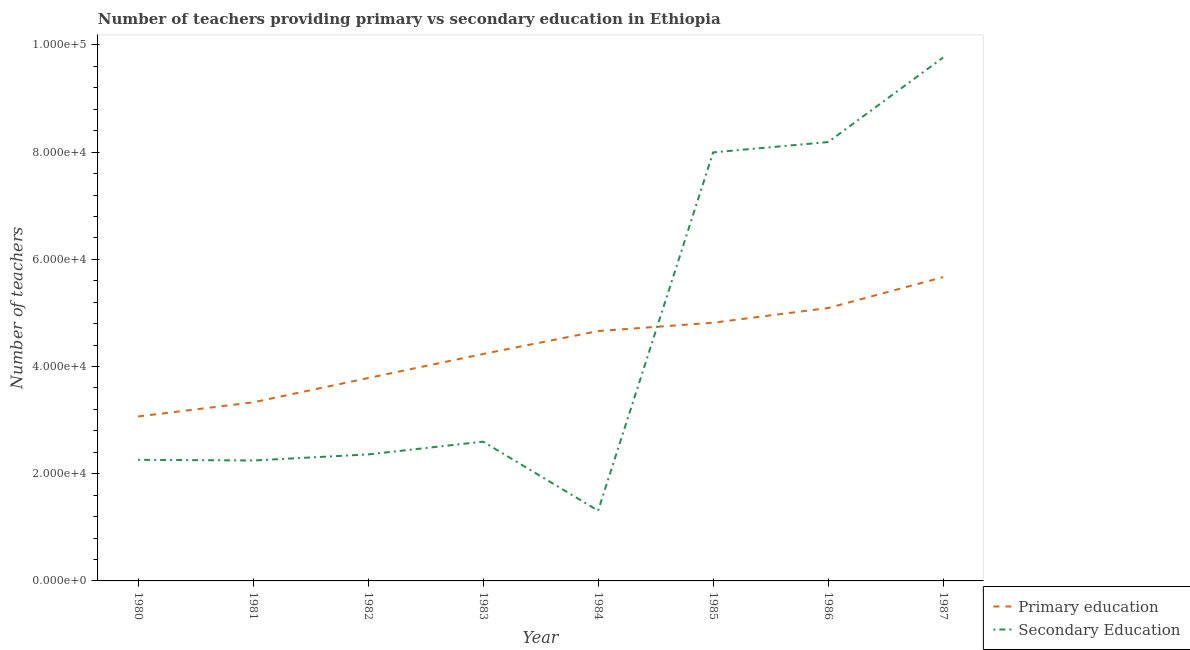How many different coloured lines are there?
Make the answer very short. 2. Is the number of lines equal to the number of legend labels?
Give a very brief answer. Yes. What is the number of primary teachers in 1980?
Ensure brevity in your answer.  3.07e+04. Across all years, what is the maximum number of secondary teachers?
Give a very brief answer. 9.77e+04. Across all years, what is the minimum number of primary teachers?
Make the answer very short. 3.07e+04. What is the total number of secondary teachers in the graph?
Offer a terse response. 3.67e+05. What is the difference between the number of secondary teachers in 1980 and that in 1982?
Ensure brevity in your answer.  -1005. What is the difference between the number of primary teachers in 1987 and the number of secondary teachers in 1984?
Provide a short and direct response. 4.36e+04. What is the average number of secondary teachers per year?
Provide a succinct answer. 4.59e+04. In the year 1982, what is the difference between the number of secondary teachers and number of primary teachers?
Your answer should be compact. -1.42e+04. In how many years, is the number of primary teachers greater than 88000?
Offer a terse response. 0. What is the ratio of the number of primary teachers in 1984 to that in 1987?
Give a very brief answer. 0.82. What is the difference between the highest and the second highest number of primary teachers?
Make the answer very short. 5762. What is the difference between the highest and the lowest number of secondary teachers?
Your answer should be very brief. 8.46e+04. Is the number of primary teachers strictly less than the number of secondary teachers over the years?
Your answer should be compact. No. How many legend labels are there?
Ensure brevity in your answer.  2. How are the legend labels stacked?
Make the answer very short. Vertical. What is the title of the graph?
Provide a succinct answer. Number of teachers providing primary vs secondary education in Ethiopia. What is the label or title of the Y-axis?
Offer a terse response. Number of teachers. What is the Number of teachers of Primary education in 1980?
Make the answer very short. 3.07e+04. What is the Number of teachers in Secondary Education in 1980?
Keep it short and to the point. 2.26e+04. What is the Number of teachers in Primary education in 1981?
Your response must be concise. 3.33e+04. What is the Number of teachers of Secondary Education in 1981?
Keep it short and to the point. 2.25e+04. What is the Number of teachers of Primary education in 1982?
Your answer should be very brief. 3.79e+04. What is the Number of teachers in Secondary Education in 1982?
Your answer should be very brief. 2.36e+04. What is the Number of teachers of Primary education in 1983?
Your answer should be compact. 4.23e+04. What is the Number of teachers in Secondary Education in 1983?
Your answer should be very brief. 2.60e+04. What is the Number of teachers of Primary education in 1984?
Keep it short and to the point. 4.66e+04. What is the Number of teachers of Secondary Education in 1984?
Provide a short and direct response. 1.31e+04. What is the Number of teachers in Primary education in 1985?
Ensure brevity in your answer.  4.82e+04. What is the Number of teachers of Secondary Education in 1985?
Make the answer very short. 8.00e+04. What is the Number of teachers in Primary education in 1986?
Give a very brief answer. 5.09e+04. What is the Number of teachers of Secondary Education in 1986?
Your answer should be very brief. 8.19e+04. What is the Number of teachers in Primary education in 1987?
Offer a very short reply. 5.67e+04. What is the Number of teachers in Secondary Education in 1987?
Give a very brief answer. 9.77e+04. Across all years, what is the maximum Number of teachers in Primary education?
Provide a succinct answer. 5.67e+04. Across all years, what is the maximum Number of teachers of Secondary Education?
Offer a very short reply. 9.77e+04. Across all years, what is the minimum Number of teachers of Primary education?
Your answer should be compact. 3.07e+04. Across all years, what is the minimum Number of teachers in Secondary Education?
Your answer should be compact. 1.31e+04. What is the total Number of teachers in Primary education in the graph?
Make the answer very short. 3.47e+05. What is the total Number of teachers in Secondary Education in the graph?
Make the answer very short. 3.67e+05. What is the difference between the Number of teachers of Primary education in 1980 and that in 1981?
Your answer should be very brief. -2635. What is the difference between the Number of teachers of Secondary Education in 1980 and that in 1981?
Provide a succinct answer. 130. What is the difference between the Number of teachers of Primary education in 1980 and that in 1982?
Make the answer very short. -7167. What is the difference between the Number of teachers of Secondary Education in 1980 and that in 1982?
Provide a short and direct response. -1005. What is the difference between the Number of teachers in Primary education in 1980 and that in 1983?
Offer a very short reply. -1.17e+04. What is the difference between the Number of teachers in Secondary Education in 1980 and that in 1983?
Provide a short and direct response. -3384. What is the difference between the Number of teachers in Primary education in 1980 and that in 1984?
Provide a succinct answer. -1.59e+04. What is the difference between the Number of teachers in Secondary Education in 1980 and that in 1984?
Your response must be concise. 9491. What is the difference between the Number of teachers of Primary education in 1980 and that in 1985?
Make the answer very short. -1.75e+04. What is the difference between the Number of teachers of Secondary Education in 1980 and that in 1985?
Provide a succinct answer. -5.74e+04. What is the difference between the Number of teachers in Primary education in 1980 and that in 1986?
Provide a short and direct response. -2.02e+04. What is the difference between the Number of teachers in Secondary Education in 1980 and that in 1986?
Your answer should be compact. -5.93e+04. What is the difference between the Number of teachers in Primary education in 1980 and that in 1987?
Your response must be concise. -2.60e+04. What is the difference between the Number of teachers in Secondary Education in 1980 and that in 1987?
Provide a short and direct response. -7.51e+04. What is the difference between the Number of teachers of Primary education in 1981 and that in 1982?
Provide a succinct answer. -4532. What is the difference between the Number of teachers of Secondary Education in 1981 and that in 1982?
Ensure brevity in your answer.  -1135. What is the difference between the Number of teachers in Primary education in 1981 and that in 1983?
Provide a short and direct response. -9025. What is the difference between the Number of teachers of Secondary Education in 1981 and that in 1983?
Your answer should be compact. -3514. What is the difference between the Number of teachers of Primary education in 1981 and that in 1984?
Provide a short and direct response. -1.33e+04. What is the difference between the Number of teachers of Secondary Education in 1981 and that in 1984?
Your response must be concise. 9361. What is the difference between the Number of teachers in Primary education in 1981 and that in 1985?
Give a very brief answer. -1.49e+04. What is the difference between the Number of teachers of Secondary Education in 1981 and that in 1985?
Make the answer very short. -5.75e+04. What is the difference between the Number of teachers of Primary education in 1981 and that in 1986?
Offer a terse response. -1.76e+04. What is the difference between the Number of teachers of Secondary Education in 1981 and that in 1986?
Offer a terse response. -5.94e+04. What is the difference between the Number of teachers in Primary education in 1981 and that in 1987?
Ensure brevity in your answer.  -2.34e+04. What is the difference between the Number of teachers in Secondary Education in 1981 and that in 1987?
Your answer should be very brief. -7.52e+04. What is the difference between the Number of teachers in Primary education in 1982 and that in 1983?
Make the answer very short. -4493. What is the difference between the Number of teachers of Secondary Education in 1982 and that in 1983?
Keep it short and to the point. -2379. What is the difference between the Number of teachers in Primary education in 1982 and that in 1984?
Offer a very short reply. -8768. What is the difference between the Number of teachers of Secondary Education in 1982 and that in 1984?
Your answer should be compact. 1.05e+04. What is the difference between the Number of teachers of Primary education in 1982 and that in 1985?
Provide a succinct answer. -1.03e+04. What is the difference between the Number of teachers in Secondary Education in 1982 and that in 1985?
Provide a short and direct response. -5.64e+04. What is the difference between the Number of teachers in Primary education in 1982 and that in 1986?
Offer a very short reply. -1.31e+04. What is the difference between the Number of teachers of Secondary Education in 1982 and that in 1986?
Provide a short and direct response. -5.83e+04. What is the difference between the Number of teachers in Primary education in 1982 and that in 1987?
Ensure brevity in your answer.  -1.88e+04. What is the difference between the Number of teachers of Secondary Education in 1982 and that in 1987?
Give a very brief answer. -7.41e+04. What is the difference between the Number of teachers of Primary education in 1983 and that in 1984?
Your answer should be very brief. -4275. What is the difference between the Number of teachers in Secondary Education in 1983 and that in 1984?
Your response must be concise. 1.29e+04. What is the difference between the Number of teachers in Primary education in 1983 and that in 1985?
Provide a succinct answer. -5831. What is the difference between the Number of teachers in Secondary Education in 1983 and that in 1985?
Your answer should be very brief. -5.40e+04. What is the difference between the Number of teachers in Primary education in 1983 and that in 1986?
Offer a terse response. -8575. What is the difference between the Number of teachers in Secondary Education in 1983 and that in 1986?
Your answer should be compact. -5.59e+04. What is the difference between the Number of teachers in Primary education in 1983 and that in 1987?
Offer a very short reply. -1.43e+04. What is the difference between the Number of teachers of Secondary Education in 1983 and that in 1987?
Offer a terse response. -7.17e+04. What is the difference between the Number of teachers in Primary education in 1984 and that in 1985?
Give a very brief answer. -1556. What is the difference between the Number of teachers of Secondary Education in 1984 and that in 1985?
Your answer should be very brief. -6.69e+04. What is the difference between the Number of teachers of Primary education in 1984 and that in 1986?
Ensure brevity in your answer.  -4300. What is the difference between the Number of teachers in Secondary Education in 1984 and that in 1986?
Make the answer very short. -6.88e+04. What is the difference between the Number of teachers of Primary education in 1984 and that in 1987?
Your answer should be very brief. -1.01e+04. What is the difference between the Number of teachers of Secondary Education in 1984 and that in 1987?
Offer a very short reply. -8.46e+04. What is the difference between the Number of teachers in Primary education in 1985 and that in 1986?
Keep it short and to the point. -2744. What is the difference between the Number of teachers in Secondary Education in 1985 and that in 1986?
Offer a very short reply. -1925. What is the difference between the Number of teachers in Primary education in 1985 and that in 1987?
Keep it short and to the point. -8506. What is the difference between the Number of teachers in Secondary Education in 1985 and that in 1987?
Provide a short and direct response. -1.77e+04. What is the difference between the Number of teachers of Primary education in 1986 and that in 1987?
Offer a very short reply. -5762. What is the difference between the Number of teachers in Secondary Education in 1986 and that in 1987?
Offer a terse response. -1.58e+04. What is the difference between the Number of teachers of Primary education in 1980 and the Number of teachers of Secondary Education in 1981?
Offer a very short reply. 8217. What is the difference between the Number of teachers of Primary education in 1980 and the Number of teachers of Secondary Education in 1982?
Keep it short and to the point. 7082. What is the difference between the Number of teachers of Primary education in 1980 and the Number of teachers of Secondary Education in 1983?
Ensure brevity in your answer.  4703. What is the difference between the Number of teachers in Primary education in 1980 and the Number of teachers in Secondary Education in 1984?
Your answer should be compact. 1.76e+04. What is the difference between the Number of teachers of Primary education in 1980 and the Number of teachers of Secondary Education in 1985?
Offer a terse response. -4.93e+04. What is the difference between the Number of teachers of Primary education in 1980 and the Number of teachers of Secondary Education in 1986?
Offer a very short reply. -5.12e+04. What is the difference between the Number of teachers of Primary education in 1980 and the Number of teachers of Secondary Education in 1987?
Offer a terse response. -6.70e+04. What is the difference between the Number of teachers of Primary education in 1981 and the Number of teachers of Secondary Education in 1982?
Ensure brevity in your answer.  9717. What is the difference between the Number of teachers in Primary education in 1981 and the Number of teachers in Secondary Education in 1983?
Provide a succinct answer. 7338. What is the difference between the Number of teachers in Primary education in 1981 and the Number of teachers in Secondary Education in 1984?
Offer a terse response. 2.02e+04. What is the difference between the Number of teachers in Primary education in 1981 and the Number of teachers in Secondary Education in 1985?
Keep it short and to the point. -4.66e+04. What is the difference between the Number of teachers of Primary education in 1981 and the Number of teachers of Secondary Education in 1986?
Make the answer very short. -4.86e+04. What is the difference between the Number of teachers of Primary education in 1981 and the Number of teachers of Secondary Education in 1987?
Offer a terse response. -6.43e+04. What is the difference between the Number of teachers in Primary education in 1982 and the Number of teachers in Secondary Education in 1983?
Give a very brief answer. 1.19e+04. What is the difference between the Number of teachers of Primary education in 1982 and the Number of teachers of Secondary Education in 1984?
Offer a terse response. 2.47e+04. What is the difference between the Number of teachers in Primary education in 1982 and the Number of teachers in Secondary Education in 1985?
Your answer should be compact. -4.21e+04. What is the difference between the Number of teachers of Primary education in 1982 and the Number of teachers of Secondary Education in 1986?
Your answer should be compact. -4.40e+04. What is the difference between the Number of teachers in Primary education in 1982 and the Number of teachers in Secondary Education in 1987?
Your response must be concise. -5.98e+04. What is the difference between the Number of teachers in Primary education in 1983 and the Number of teachers in Secondary Education in 1984?
Your response must be concise. 2.92e+04. What is the difference between the Number of teachers of Primary education in 1983 and the Number of teachers of Secondary Education in 1985?
Your response must be concise. -3.76e+04. What is the difference between the Number of teachers of Primary education in 1983 and the Number of teachers of Secondary Education in 1986?
Your answer should be compact. -3.95e+04. What is the difference between the Number of teachers in Primary education in 1983 and the Number of teachers in Secondary Education in 1987?
Offer a very short reply. -5.53e+04. What is the difference between the Number of teachers in Primary education in 1984 and the Number of teachers in Secondary Education in 1985?
Give a very brief answer. -3.33e+04. What is the difference between the Number of teachers in Primary education in 1984 and the Number of teachers in Secondary Education in 1986?
Make the answer very short. -3.53e+04. What is the difference between the Number of teachers in Primary education in 1984 and the Number of teachers in Secondary Education in 1987?
Provide a short and direct response. -5.10e+04. What is the difference between the Number of teachers in Primary education in 1985 and the Number of teachers in Secondary Education in 1986?
Make the answer very short. -3.37e+04. What is the difference between the Number of teachers in Primary education in 1985 and the Number of teachers in Secondary Education in 1987?
Make the answer very short. -4.95e+04. What is the difference between the Number of teachers in Primary education in 1986 and the Number of teachers in Secondary Education in 1987?
Your answer should be very brief. -4.67e+04. What is the average Number of teachers of Primary education per year?
Ensure brevity in your answer.  4.33e+04. What is the average Number of teachers in Secondary Education per year?
Provide a short and direct response. 4.59e+04. In the year 1980, what is the difference between the Number of teachers in Primary education and Number of teachers in Secondary Education?
Keep it short and to the point. 8087. In the year 1981, what is the difference between the Number of teachers of Primary education and Number of teachers of Secondary Education?
Your answer should be very brief. 1.09e+04. In the year 1982, what is the difference between the Number of teachers in Primary education and Number of teachers in Secondary Education?
Provide a succinct answer. 1.42e+04. In the year 1983, what is the difference between the Number of teachers of Primary education and Number of teachers of Secondary Education?
Your answer should be compact. 1.64e+04. In the year 1984, what is the difference between the Number of teachers in Primary education and Number of teachers in Secondary Education?
Keep it short and to the point. 3.35e+04. In the year 1985, what is the difference between the Number of teachers in Primary education and Number of teachers in Secondary Education?
Keep it short and to the point. -3.18e+04. In the year 1986, what is the difference between the Number of teachers in Primary education and Number of teachers in Secondary Education?
Make the answer very short. -3.10e+04. In the year 1987, what is the difference between the Number of teachers of Primary education and Number of teachers of Secondary Education?
Offer a terse response. -4.10e+04. What is the ratio of the Number of teachers of Primary education in 1980 to that in 1981?
Ensure brevity in your answer.  0.92. What is the ratio of the Number of teachers in Primary education in 1980 to that in 1982?
Keep it short and to the point. 0.81. What is the ratio of the Number of teachers in Secondary Education in 1980 to that in 1982?
Provide a short and direct response. 0.96. What is the ratio of the Number of teachers of Primary education in 1980 to that in 1983?
Offer a terse response. 0.72. What is the ratio of the Number of teachers of Secondary Education in 1980 to that in 1983?
Your response must be concise. 0.87. What is the ratio of the Number of teachers of Primary education in 1980 to that in 1984?
Your response must be concise. 0.66. What is the ratio of the Number of teachers in Secondary Education in 1980 to that in 1984?
Make the answer very short. 1.72. What is the ratio of the Number of teachers in Primary education in 1980 to that in 1985?
Keep it short and to the point. 0.64. What is the ratio of the Number of teachers of Secondary Education in 1980 to that in 1985?
Offer a very short reply. 0.28. What is the ratio of the Number of teachers in Primary education in 1980 to that in 1986?
Provide a succinct answer. 0.6. What is the ratio of the Number of teachers of Secondary Education in 1980 to that in 1986?
Your answer should be very brief. 0.28. What is the ratio of the Number of teachers of Primary education in 1980 to that in 1987?
Your answer should be compact. 0.54. What is the ratio of the Number of teachers in Secondary Education in 1980 to that in 1987?
Offer a terse response. 0.23. What is the ratio of the Number of teachers of Primary education in 1981 to that in 1982?
Your response must be concise. 0.88. What is the ratio of the Number of teachers in Secondary Education in 1981 to that in 1982?
Make the answer very short. 0.95. What is the ratio of the Number of teachers of Primary education in 1981 to that in 1983?
Make the answer very short. 0.79. What is the ratio of the Number of teachers in Secondary Education in 1981 to that in 1983?
Your answer should be compact. 0.86. What is the ratio of the Number of teachers of Primary education in 1981 to that in 1984?
Give a very brief answer. 0.71. What is the ratio of the Number of teachers in Secondary Education in 1981 to that in 1984?
Keep it short and to the point. 1.71. What is the ratio of the Number of teachers of Primary education in 1981 to that in 1985?
Your answer should be compact. 0.69. What is the ratio of the Number of teachers in Secondary Education in 1981 to that in 1985?
Ensure brevity in your answer.  0.28. What is the ratio of the Number of teachers in Primary education in 1981 to that in 1986?
Provide a succinct answer. 0.65. What is the ratio of the Number of teachers in Secondary Education in 1981 to that in 1986?
Give a very brief answer. 0.27. What is the ratio of the Number of teachers of Primary education in 1981 to that in 1987?
Give a very brief answer. 0.59. What is the ratio of the Number of teachers in Secondary Education in 1981 to that in 1987?
Offer a terse response. 0.23. What is the ratio of the Number of teachers in Primary education in 1982 to that in 1983?
Your answer should be compact. 0.89. What is the ratio of the Number of teachers in Secondary Education in 1982 to that in 1983?
Provide a succinct answer. 0.91. What is the ratio of the Number of teachers of Primary education in 1982 to that in 1984?
Offer a terse response. 0.81. What is the ratio of the Number of teachers in Secondary Education in 1982 to that in 1984?
Offer a terse response. 1.8. What is the ratio of the Number of teachers in Primary education in 1982 to that in 1985?
Your answer should be very brief. 0.79. What is the ratio of the Number of teachers of Secondary Education in 1982 to that in 1985?
Your answer should be compact. 0.3. What is the ratio of the Number of teachers of Primary education in 1982 to that in 1986?
Your answer should be compact. 0.74. What is the ratio of the Number of teachers in Secondary Education in 1982 to that in 1986?
Your answer should be compact. 0.29. What is the ratio of the Number of teachers of Primary education in 1982 to that in 1987?
Provide a short and direct response. 0.67. What is the ratio of the Number of teachers of Secondary Education in 1982 to that in 1987?
Ensure brevity in your answer.  0.24. What is the ratio of the Number of teachers of Primary education in 1983 to that in 1984?
Give a very brief answer. 0.91. What is the ratio of the Number of teachers of Secondary Education in 1983 to that in 1984?
Your response must be concise. 1.98. What is the ratio of the Number of teachers of Primary education in 1983 to that in 1985?
Your response must be concise. 0.88. What is the ratio of the Number of teachers in Secondary Education in 1983 to that in 1985?
Provide a succinct answer. 0.33. What is the ratio of the Number of teachers in Primary education in 1983 to that in 1986?
Give a very brief answer. 0.83. What is the ratio of the Number of teachers of Secondary Education in 1983 to that in 1986?
Offer a terse response. 0.32. What is the ratio of the Number of teachers in Primary education in 1983 to that in 1987?
Give a very brief answer. 0.75. What is the ratio of the Number of teachers of Secondary Education in 1983 to that in 1987?
Provide a short and direct response. 0.27. What is the ratio of the Number of teachers of Primary education in 1984 to that in 1985?
Ensure brevity in your answer.  0.97. What is the ratio of the Number of teachers of Secondary Education in 1984 to that in 1985?
Make the answer very short. 0.16. What is the ratio of the Number of teachers in Primary education in 1984 to that in 1986?
Give a very brief answer. 0.92. What is the ratio of the Number of teachers in Secondary Education in 1984 to that in 1986?
Provide a succinct answer. 0.16. What is the ratio of the Number of teachers of Primary education in 1984 to that in 1987?
Ensure brevity in your answer.  0.82. What is the ratio of the Number of teachers in Secondary Education in 1984 to that in 1987?
Your answer should be compact. 0.13. What is the ratio of the Number of teachers of Primary education in 1985 to that in 1986?
Provide a succinct answer. 0.95. What is the ratio of the Number of teachers of Secondary Education in 1985 to that in 1986?
Offer a very short reply. 0.98. What is the ratio of the Number of teachers in Primary education in 1985 to that in 1987?
Keep it short and to the point. 0.85. What is the ratio of the Number of teachers in Secondary Education in 1985 to that in 1987?
Offer a terse response. 0.82. What is the ratio of the Number of teachers of Primary education in 1986 to that in 1987?
Offer a terse response. 0.9. What is the ratio of the Number of teachers of Secondary Education in 1986 to that in 1987?
Give a very brief answer. 0.84. What is the difference between the highest and the second highest Number of teachers in Primary education?
Your answer should be compact. 5762. What is the difference between the highest and the second highest Number of teachers of Secondary Education?
Give a very brief answer. 1.58e+04. What is the difference between the highest and the lowest Number of teachers of Primary education?
Offer a terse response. 2.60e+04. What is the difference between the highest and the lowest Number of teachers in Secondary Education?
Offer a very short reply. 8.46e+04. 